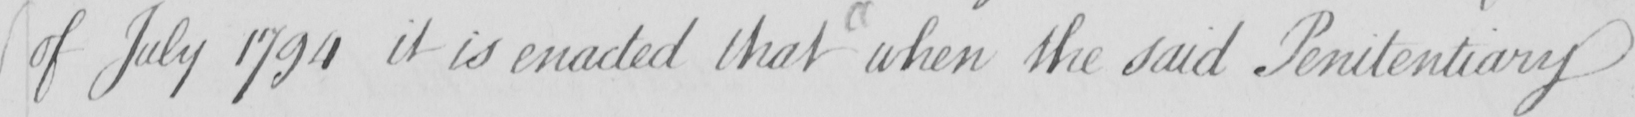What is written in this line of handwriting? of July 1794 it is enacted that when the said Penitentiary 